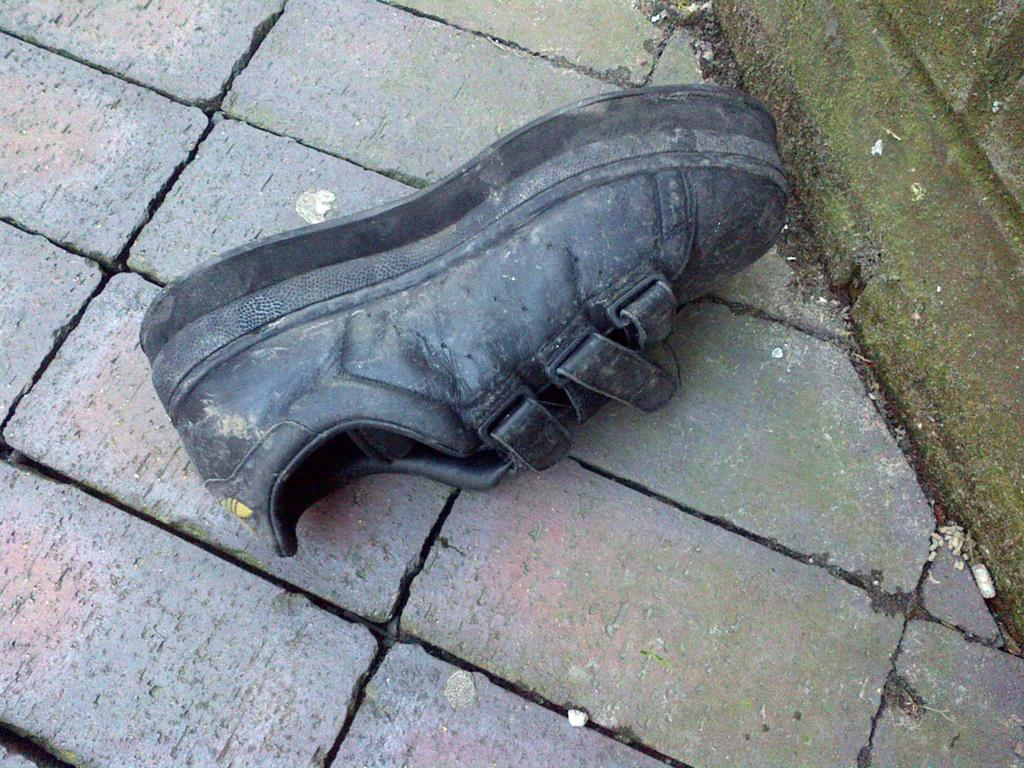What is the main object in the middle of the image? There is a black boot or shoe in the middle of the image. What type of surface is visible at the bottom of the image? The pavement is visible at the bottom of the image. What can be seen on the right side of the image? There is a wall on the right side of the image. What is the condition of the wall in the image? The wall is covered with algae. What type of linen is draped over the boot in the image? There is no linen draped over the boot in the image; it is a black boot or shoe standing on the pavement. What is the temper of the person who owns the boot in the image? There is no information about the temper of the person who owns the boot in the image. 